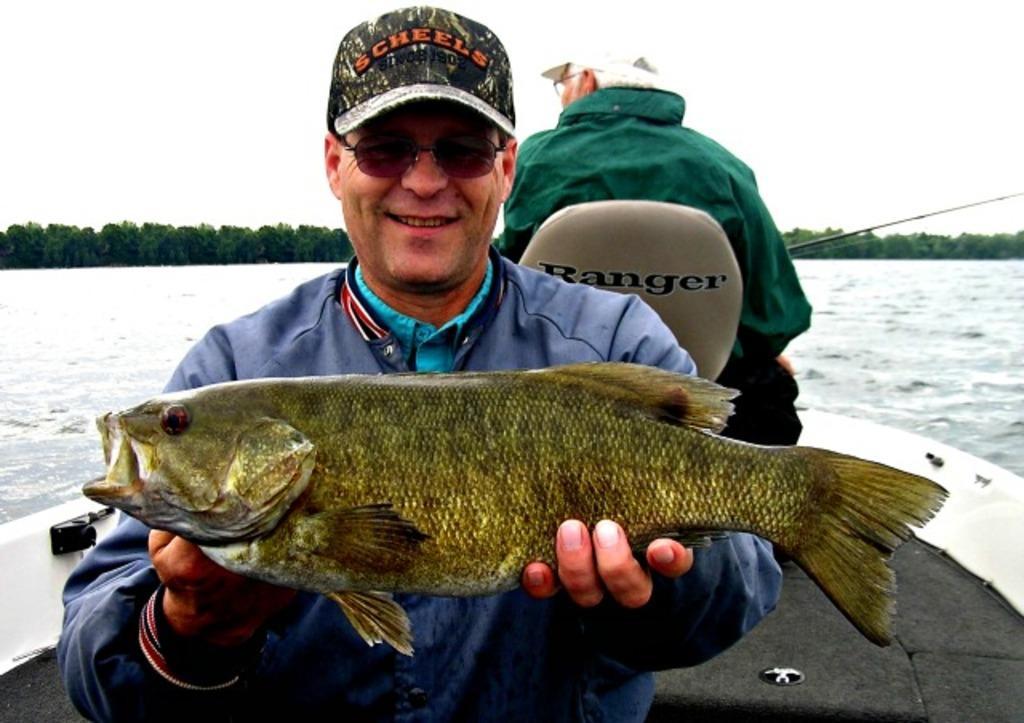Could you give a brief overview of what you see in this image? In this image we can see two men in a boat which is in a large water body. In that a man is holding a fish and the other is sitting on the chair holding a fishing rod. On the backside we can see a group of trees and the sky. 